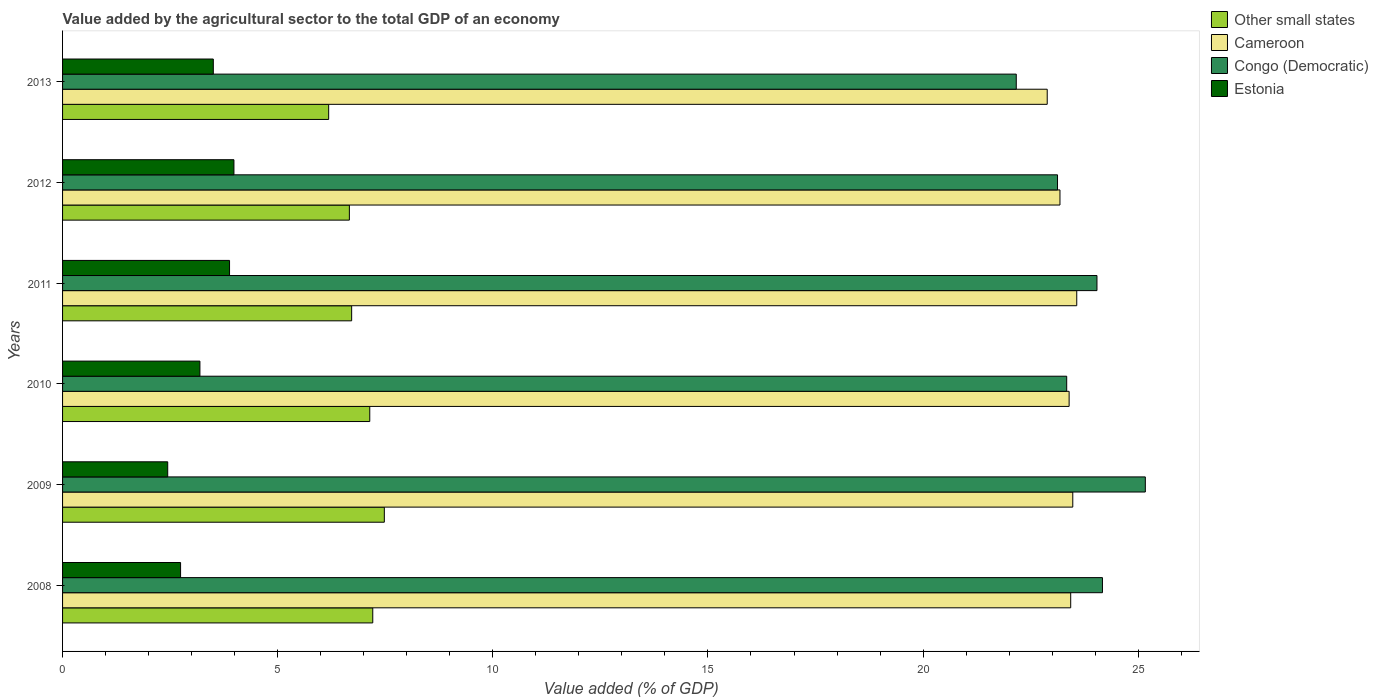Are the number of bars per tick equal to the number of legend labels?
Provide a succinct answer. Yes. Are the number of bars on each tick of the Y-axis equal?
Give a very brief answer. Yes. How many bars are there on the 5th tick from the top?
Give a very brief answer. 4. How many bars are there on the 3rd tick from the bottom?
Ensure brevity in your answer.  4. What is the value added by the agricultural sector to the total GDP in Other small states in 2011?
Keep it short and to the point. 6.72. Across all years, what is the maximum value added by the agricultural sector to the total GDP in Estonia?
Keep it short and to the point. 3.98. Across all years, what is the minimum value added by the agricultural sector to the total GDP in Other small states?
Your answer should be very brief. 6.18. In which year was the value added by the agricultural sector to the total GDP in Congo (Democratic) maximum?
Your answer should be compact. 2009. In which year was the value added by the agricultural sector to the total GDP in Cameroon minimum?
Your response must be concise. 2013. What is the total value added by the agricultural sector to the total GDP in Estonia in the graph?
Your answer should be compact. 19.75. What is the difference between the value added by the agricultural sector to the total GDP in Congo (Democratic) in 2009 and that in 2012?
Provide a short and direct response. 2.04. What is the difference between the value added by the agricultural sector to the total GDP in Estonia in 2010 and the value added by the agricultural sector to the total GDP in Congo (Democratic) in 2008?
Provide a short and direct response. -20.98. What is the average value added by the agricultural sector to the total GDP in Other small states per year?
Ensure brevity in your answer.  6.9. In the year 2009, what is the difference between the value added by the agricultural sector to the total GDP in Congo (Democratic) and value added by the agricultural sector to the total GDP in Cameroon?
Make the answer very short. 1.69. What is the ratio of the value added by the agricultural sector to the total GDP in Cameroon in 2012 to that in 2013?
Offer a very short reply. 1.01. What is the difference between the highest and the second highest value added by the agricultural sector to the total GDP in Cameroon?
Make the answer very short. 0.09. What is the difference between the highest and the lowest value added by the agricultural sector to the total GDP in Estonia?
Offer a terse response. 1.54. In how many years, is the value added by the agricultural sector to the total GDP in Congo (Democratic) greater than the average value added by the agricultural sector to the total GDP in Congo (Democratic) taken over all years?
Ensure brevity in your answer.  3. Is the sum of the value added by the agricultural sector to the total GDP in Cameroon in 2010 and 2011 greater than the maximum value added by the agricultural sector to the total GDP in Congo (Democratic) across all years?
Provide a short and direct response. Yes. What does the 2nd bar from the top in 2011 represents?
Keep it short and to the point. Congo (Democratic). What does the 4th bar from the bottom in 2009 represents?
Offer a very short reply. Estonia. Is it the case that in every year, the sum of the value added by the agricultural sector to the total GDP in Cameroon and value added by the agricultural sector to the total GDP in Congo (Democratic) is greater than the value added by the agricultural sector to the total GDP in Estonia?
Make the answer very short. Yes. Are all the bars in the graph horizontal?
Your response must be concise. Yes. Where does the legend appear in the graph?
Your response must be concise. Top right. What is the title of the graph?
Make the answer very short. Value added by the agricultural sector to the total GDP of an economy. Does "Europe(developing only)" appear as one of the legend labels in the graph?
Make the answer very short. No. What is the label or title of the X-axis?
Ensure brevity in your answer.  Value added (% of GDP). What is the label or title of the Y-axis?
Ensure brevity in your answer.  Years. What is the Value added (% of GDP) of Other small states in 2008?
Provide a succinct answer. 7.21. What is the Value added (% of GDP) in Cameroon in 2008?
Offer a terse response. 23.43. What is the Value added (% of GDP) in Congo (Democratic) in 2008?
Ensure brevity in your answer.  24.17. What is the Value added (% of GDP) in Estonia in 2008?
Keep it short and to the point. 2.74. What is the Value added (% of GDP) in Other small states in 2009?
Give a very brief answer. 7.48. What is the Value added (% of GDP) of Cameroon in 2009?
Give a very brief answer. 23.48. What is the Value added (% of GDP) in Congo (Democratic) in 2009?
Keep it short and to the point. 25.16. What is the Value added (% of GDP) in Estonia in 2009?
Ensure brevity in your answer.  2.44. What is the Value added (% of GDP) in Other small states in 2010?
Ensure brevity in your answer.  7.14. What is the Value added (% of GDP) of Cameroon in 2010?
Keep it short and to the point. 23.39. What is the Value added (% of GDP) in Congo (Democratic) in 2010?
Provide a succinct answer. 23.34. What is the Value added (% of GDP) of Estonia in 2010?
Offer a very short reply. 3.19. What is the Value added (% of GDP) of Other small states in 2011?
Ensure brevity in your answer.  6.72. What is the Value added (% of GDP) in Cameroon in 2011?
Ensure brevity in your answer.  23.57. What is the Value added (% of GDP) of Congo (Democratic) in 2011?
Your answer should be very brief. 24.04. What is the Value added (% of GDP) of Estonia in 2011?
Keep it short and to the point. 3.88. What is the Value added (% of GDP) in Other small states in 2012?
Offer a very short reply. 6.67. What is the Value added (% of GDP) in Cameroon in 2012?
Provide a short and direct response. 23.18. What is the Value added (% of GDP) in Congo (Democratic) in 2012?
Provide a succinct answer. 23.12. What is the Value added (% of GDP) in Estonia in 2012?
Offer a very short reply. 3.98. What is the Value added (% of GDP) of Other small states in 2013?
Your answer should be compact. 6.18. What is the Value added (% of GDP) of Cameroon in 2013?
Ensure brevity in your answer.  22.89. What is the Value added (% of GDP) in Congo (Democratic) in 2013?
Ensure brevity in your answer.  22.17. What is the Value added (% of GDP) in Estonia in 2013?
Make the answer very short. 3.5. Across all years, what is the maximum Value added (% of GDP) of Other small states?
Your response must be concise. 7.48. Across all years, what is the maximum Value added (% of GDP) of Cameroon?
Your response must be concise. 23.57. Across all years, what is the maximum Value added (% of GDP) of Congo (Democratic)?
Your response must be concise. 25.16. Across all years, what is the maximum Value added (% of GDP) of Estonia?
Your answer should be very brief. 3.98. Across all years, what is the minimum Value added (% of GDP) in Other small states?
Your answer should be very brief. 6.18. Across all years, what is the minimum Value added (% of GDP) in Cameroon?
Your answer should be compact. 22.89. Across all years, what is the minimum Value added (% of GDP) in Congo (Democratic)?
Give a very brief answer. 22.17. Across all years, what is the minimum Value added (% of GDP) of Estonia?
Offer a very short reply. 2.44. What is the total Value added (% of GDP) of Other small states in the graph?
Ensure brevity in your answer.  41.4. What is the total Value added (% of GDP) in Cameroon in the graph?
Provide a succinct answer. 139.94. What is the total Value added (% of GDP) in Congo (Democratic) in the graph?
Provide a short and direct response. 142. What is the total Value added (% of GDP) in Estonia in the graph?
Offer a very short reply. 19.75. What is the difference between the Value added (% of GDP) of Other small states in 2008 and that in 2009?
Make the answer very short. -0.27. What is the difference between the Value added (% of GDP) of Cameroon in 2008 and that in 2009?
Provide a short and direct response. -0.05. What is the difference between the Value added (% of GDP) in Congo (Democratic) in 2008 and that in 2009?
Your answer should be very brief. -1. What is the difference between the Value added (% of GDP) of Estonia in 2008 and that in 2009?
Provide a short and direct response. 0.3. What is the difference between the Value added (% of GDP) in Other small states in 2008 and that in 2010?
Offer a terse response. 0.07. What is the difference between the Value added (% of GDP) in Cameroon in 2008 and that in 2010?
Your answer should be very brief. 0.04. What is the difference between the Value added (% of GDP) of Congo (Democratic) in 2008 and that in 2010?
Provide a short and direct response. 0.83. What is the difference between the Value added (% of GDP) of Estonia in 2008 and that in 2010?
Provide a succinct answer. -0.45. What is the difference between the Value added (% of GDP) of Other small states in 2008 and that in 2011?
Make the answer very short. 0.49. What is the difference between the Value added (% of GDP) of Cameroon in 2008 and that in 2011?
Make the answer very short. -0.14. What is the difference between the Value added (% of GDP) of Congo (Democratic) in 2008 and that in 2011?
Give a very brief answer. 0.13. What is the difference between the Value added (% of GDP) in Estonia in 2008 and that in 2011?
Your response must be concise. -1.14. What is the difference between the Value added (% of GDP) of Other small states in 2008 and that in 2012?
Give a very brief answer. 0.54. What is the difference between the Value added (% of GDP) of Cameroon in 2008 and that in 2012?
Provide a short and direct response. 0.25. What is the difference between the Value added (% of GDP) in Congo (Democratic) in 2008 and that in 2012?
Your answer should be very brief. 1.04. What is the difference between the Value added (% of GDP) of Estonia in 2008 and that in 2012?
Offer a very short reply. -1.24. What is the difference between the Value added (% of GDP) of Cameroon in 2008 and that in 2013?
Your answer should be very brief. 0.55. What is the difference between the Value added (% of GDP) of Congo (Democratic) in 2008 and that in 2013?
Give a very brief answer. 2. What is the difference between the Value added (% of GDP) of Estonia in 2008 and that in 2013?
Your answer should be very brief. -0.76. What is the difference between the Value added (% of GDP) of Other small states in 2009 and that in 2010?
Offer a terse response. 0.34. What is the difference between the Value added (% of GDP) of Cameroon in 2009 and that in 2010?
Provide a succinct answer. 0.08. What is the difference between the Value added (% of GDP) of Congo (Democratic) in 2009 and that in 2010?
Ensure brevity in your answer.  1.83. What is the difference between the Value added (% of GDP) in Estonia in 2009 and that in 2010?
Make the answer very short. -0.75. What is the difference between the Value added (% of GDP) in Other small states in 2009 and that in 2011?
Provide a short and direct response. 0.76. What is the difference between the Value added (% of GDP) of Cameroon in 2009 and that in 2011?
Your answer should be very brief. -0.09. What is the difference between the Value added (% of GDP) in Congo (Democratic) in 2009 and that in 2011?
Ensure brevity in your answer.  1.12. What is the difference between the Value added (% of GDP) of Estonia in 2009 and that in 2011?
Offer a terse response. -1.44. What is the difference between the Value added (% of GDP) in Other small states in 2009 and that in 2012?
Give a very brief answer. 0.81. What is the difference between the Value added (% of GDP) of Cameroon in 2009 and that in 2012?
Offer a terse response. 0.3. What is the difference between the Value added (% of GDP) in Congo (Democratic) in 2009 and that in 2012?
Make the answer very short. 2.04. What is the difference between the Value added (% of GDP) in Estonia in 2009 and that in 2012?
Offer a very short reply. -1.54. What is the difference between the Value added (% of GDP) in Other small states in 2009 and that in 2013?
Keep it short and to the point. 1.29. What is the difference between the Value added (% of GDP) of Cameroon in 2009 and that in 2013?
Your answer should be very brief. 0.59. What is the difference between the Value added (% of GDP) in Congo (Democratic) in 2009 and that in 2013?
Offer a very short reply. 3. What is the difference between the Value added (% of GDP) of Estonia in 2009 and that in 2013?
Offer a very short reply. -1.06. What is the difference between the Value added (% of GDP) in Other small states in 2010 and that in 2011?
Offer a very short reply. 0.42. What is the difference between the Value added (% of GDP) in Cameroon in 2010 and that in 2011?
Keep it short and to the point. -0.18. What is the difference between the Value added (% of GDP) in Congo (Democratic) in 2010 and that in 2011?
Keep it short and to the point. -0.7. What is the difference between the Value added (% of GDP) in Estonia in 2010 and that in 2011?
Offer a terse response. -0.69. What is the difference between the Value added (% of GDP) of Other small states in 2010 and that in 2012?
Your answer should be compact. 0.47. What is the difference between the Value added (% of GDP) of Cameroon in 2010 and that in 2012?
Your answer should be very brief. 0.21. What is the difference between the Value added (% of GDP) in Congo (Democratic) in 2010 and that in 2012?
Your answer should be very brief. 0.21. What is the difference between the Value added (% of GDP) in Estonia in 2010 and that in 2012?
Provide a short and direct response. -0.79. What is the difference between the Value added (% of GDP) in Other small states in 2010 and that in 2013?
Provide a succinct answer. 0.96. What is the difference between the Value added (% of GDP) of Cameroon in 2010 and that in 2013?
Offer a terse response. 0.51. What is the difference between the Value added (% of GDP) of Congo (Democratic) in 2010 and that in 2013?
Your response must be concise. 1.17. What is the difference between the Value added (% of GDP) in Estonia in 2010 and that in 2013?
Your response must be concise. -0.31. What is the difference between the Value added (% of GDP) in Other small states in 2011 and that in 2012?
Your response must be concise. 0.05. What is the difference between the Value added (% of GDP) in Cameroon in 2011 and that in 2012?
Ensure brevity in your answer.  0.39. What is the difference between the Value added (% of GDP) in Congo (Democratic) in 2011 and that in 2012?
Keep it short and to the point. 0.92. What is the difference between the Value added (% of GDP) in Estonia in 2011 and that in 2012?
Your answer should be very brief. -0.1. What is the difference between the Value added (% of GDP) of Other small states in 2011 and that in 2013?
Offer a terse response. 0.53. What is the difference between the Value added (% of GDP) in Cameroon in 2011 and that in 2013?
Provide a succinct answer. 0.69. What is the difference between the Value added (% of GDP) in Congo (Democratic) in 2011 and that in 2013?
Provide a succinct answer. 1.88. What is the difference between the Value added (% of GDP) of Estonia in 2011 and that in 2013?
Your response must be concise. 0.38. What is the difference between the Value added (% of GDP) of Other small states in 2012 and that in 2013?
Your answer should be compact. 0.48. What is the difference between the Value added (% of GDP) in Cameroon in 2012 and that in 2013?
Provide a succinct answer. 0.3. What is the difference between the Value added (% of GDP) in Congo (Democratic) in 2012 and that in 2013?
Keep it short and to the point. 0.96. What is the difference between the Value added (% of GDP) of Estonia in 2012 and that in 2013?
Your answer should be very brief. 0.48. What is the difference between the Value added (% of GDP) in Other small states in 2008 and the Value added (% of GDP) in Cameroon in 2009?
Ensure brevity in your answer.  -16.27. What is the difference between the Value added (% of GDP) of Other small states in 2008 and the Value added (% of GDP) of Congo (Democratic) in 2009?
Give a very brief answer. -17.96. What is the difference between the Value added (% of GDP) in Other small states in 2008 and the Value added (% of GDP) in Estonia in 2009?
Your answer should be very brief. 4.77. What is the difference between the Value added (% of GDP) of Cameroon in 2008 and the Value added (% of GDP) of Congo (Democratic) in 2009?
Offer a terse response. -1.73. What is the difference between the Value added (% of GDP) in Cameroon in 2008 and the Value added (% of GDP) in Estonia in 2009?
Provide a succinct answer. 20.99. What is the difference between the Value added (% of GDP) of Congo (Democratic) in 2008 and the Value added (% of GDP) of Estonia in 2009?
Provide a short and direct response. 21.72. What is the difference between the Value added (% of GDP) in Other small states in 2008 and the Value added (% of GDP) in Cameroon in 2010?
Offer a terse response. -16.18. What is the difference between the Value added (% of GDP) in Other small states in 2008 and the Value added (% of GDP) in Congo (Democratic) in 2010?
Ensure brevity in your answer.  -16.13. What is the difference between the Value added (% of GDP) in Other small states in 2008 and the Value added (% of GDP) in Estonia in 2010?
Make the answer very short. 4.02. What is the difference between the Value added (% of GDP) of Cameroon in 2008 and the Value added (% of GDP) of Congo (Democratic) in 2010?
Your answer should be compact. 0.09. What is the difference between the Value added (% of GDP) of Cameroon in 2008 and the Value added (% of GDP) of Estonia in 2010?
Keep it short and to the point. 20.24. What is the difference between the Value added (% of GDP) in Congo (Democratic) in 2008 and the Value added (% of GDP) in Estonia in 2010?
Make the answer very short. 20.98. What is the difference between the Value added (% of GDP) in Other small states in 2008 and the Value added (% of GDP) in Cameroon in 2011?
Your answer should be compact. -16.36. What is the difference between the Value added (% of GDP) in Other small states in 2008 and the Value added (% of GDP) in Congo (Democratic) in 2011?
Your answer should be very brief. -16.83. What is the difference between the Value added (% of GDP) of Other small states in 2008 and the Value added (% of GDP) of Estonia in 2011?
Provide a succinct answer. 3.33. What is the difference between the Value added (% of GDP) in Cameroon in 2008 and the Value added (% of GDP) in Congo (Democratic) in 2011?
Make the answer very short. -0.61. What is the difference between the Value added (% of GDP) in Cameroon in 2008 and the Value added (% of GDP) in Estonia in 2011?
Provide a short and direct response. 19.55. What is the difference between the Value added (% of GDP) of Congo (Democratic) in 2008 and the Value added (% of GDP) of Estonia in 2011?
Offer a very short reply. 20.29. What is the difference between the Value added (% of GDP) in Other small states in 2008 and the Value added (% of GDP) in Cameroon in 2012?
Give a very brief answer. -15.97. What is the difference between the Value added (% of GDP) of Other small states in 2008 and the Value added (% of GDP) of Congo (Democratic) in 2012?
Provide a succinct answer. -15.91. What is the difference between the Value added (% of GDP) of Other small states in 2008 and the Value added (% of GDP) of Estonia in 2012?
Your answer should be compact. 3.23. What is the difference between the Value added (% of GDP) in Cameroon in 2008 and the Value added (% of GDP) in Congo (Democratic) in 2012?
Ensure brevity in your answer.  0.31. What is the difference between the Value added (% of GDP) in Cameroon in 2008 and the Value added (% of GDP) in Estonia in 2012?
Your response must be concise. 19.45. What is the difference between the Value added (% of GDP) of Congo (Democratic) in 2008 and the Value added (% of GDP) of Estonia in 2012?
Offer a terse response. 20.19. What is the difference between the Value added (% of GDP) in Other small states in 2008 and the Value added (% of GDP) in Cameroon in 2013?
Offer a very short reply. -15.68. What is the difference between the Value added (% of GDP) in Other small states in 2008 and the Value added (% of GDP) in Congo (Democratic) in 2013?
Offer a very short reply. -14.96. What is the difference between the Value added (% of GDP) of Other small states in 2008 and the Value added (% of GDP) of Estonia in 2013?
Provide a short and direct response. 3.71. What is the difference between the Value added (% of GDP) in Cameroon in 2008 and the Value added (% of GDP) in Congo (Democratic) in 2013?
Provide a short and direct response. 1.27. What is the difference between the Value added (% of GDP) of Cameroon in 2008 and the Value added (% of GDP) of Estonia in 2013?
Your response must be concise. 19.93. What is the difference between the Value added (% of GDP) of Congo (Democratic) in 2008 and the Value added (% of GDP) of Estonia in 2013?
Provide a short and direct response. 20.66. What is the difference between the Value added (% of GDP) in Other small states in 2009 and the Value added (% of GDP) in Cameroon in 2010?
Give a very brief answer. -15.92. What is the difference between the Value added (% of GDP) of Other small states in 2009 and the Value added (% of GDP) of Congo (Democratic) in 2010?
Keep it short and to the point. -15.86. What is the difference between the Value added (% of GDP) in Other small states in 2009 and the Value added (% of GDP) in Estonia in 2010?
Offer a very short reply. 4.29. What is the difference between the Value added (% of GDP) of Cameroon in 2009 and the Value added (% of GDP) of Congo (Democratic) in 2010?
Provide a succinct answer. 0.14. What is the difference between the Value added (% of GDP) of Cameroon in 2009 and the Value added (% of GDP) of Estonia in 2010?
Ensure brevity in your answer.  20.29. What is the difference between the Value added (% of GDP) of Congo (Democratic) in 2009 and the Value added (% of GDP) of Estonia in 2010?
Your answer should be very brief. 21.97. What is the difference between the Value added (% of GDP) in Other small states in 2009 and the Value added (% of GDP) in Cameroon in 2011?
Keep it short and to the point. -16.09. What is the difference between the Value added (% of GDP) of Other small states in 2009 and the Value added (% of GDP) of Congo (Democratic) in 2011?
Keep it short and to the point. -16.56. What is the difference between the Value added (% of GDP) of Other small states in 2009 and the Value added (% of GDP) of Estonia in 2011?
Keep it short and to the point. 3.6. What is the difference between the Value added (% of GDP) of Cameroon in 2009 and the Value added (% of GDP) of Congo (Democratic) in 2011?
Provide a succinct answer. -0.56. What is the difference between the Value added (% of GDP) of Cameroon in 2009 and the Value added (% of GDP) of Estonia in 2011?
Offer a terse response. 19.6. What is the difference between the Value added (% of GDP) of Congo (Democratic) in 2009 and the Value added (% of GDP) of Estonia in 2011?
Provide a succinct answer. 21.28. What is the difference between the Value added (% of GDP) of Other small states in 2009 and the Value added (% of GDP) of Cameroon in 2012?
Your response must be concise. -15.7. What is the difference between the Value added (% of GDP) in Other small states in 2009 and the Value added (% of GDP) in Congo (Democratic) in 2012?
Your answer should be very brief. -15.65. What is the difference between the Value added (% of GDP) in Other small states in 2009 and the Value added (% of GDP) in Estonia in 2012?
Make the answer very short. 3.5. What is the difference between the Value added (% of GDP) in Cameroon in 2009 and the Value added (% of GDP) in Congo (Democratic) in 2012?
Provide a succinct answer. 0.35. What is the difference between the Value added (% of GDP) of Cameroon in 2009 and the Value added (% of GDP) of Estonia in 2012?
Give a very brief answer. 19.5. What is the difference between the Value added (% of GDP) in Congo (Democratic) in 2009 and the Value added (% of GDP) in Estonia in 2012?
Offer a very short reply. 21.18. What is the difference between the Value added (% of GDP) in Other small states in 2009 and the Value added (% of GDP) in Cameroon in 2013?
Offer a terse response. -15.41. What is the difference between the Value added (% of GDP) in Other small states in 2009 and the Value added (% of GDP) in Congo (Democratic) in 2013?
Provide a short and direct response. -14.69. What is the difference between the Value added (% of GDP) of Other small states in 2009 and the Value added (% of GDP) of Estonia in 2013?
Give a very brief answer. 3.97. What is the difference between the Value added (% of GDP) in Cameroon in 2009 and the Value added (% of GDP) in Congo (Democratic) in 2013?
Your response must be concise. 1.31. What is the difference between the Value added (% of GDP) of Cameroon in 2009 and the Value added (% of GDP) of Estonia in 2013?
Your response must be concise. 19.98. What is the difference between the Value added (% of GDP) of Congo (Democratic) in 2009 and the Value added (% of GDP) of Estonia in 2013?
Offer a terse response. 21.66. What is the difference between the Value added (% of GDP) in Other small states in 2010 and the Value added (% of GDP) in Cameroon in 2011?
Your response must be concise. -16.43. What is the difference between the Value added (% of GDP) of Other small states in 2010 and the Value added (% of GDP) of Congo (Democratic) in 2011?
Provide a short and direct response. -16.9. What is the difference between the Value added (% of GDP) in Other small states in 2010 and the Value added (% of GDP) in Estonia in 2011?
Give a very brief answer. 3.26. What is the difference between the Value added (% of GDP) of Cameroon in 2010 and the Value added (% of GDP) of Congo (Democratic) in 2011?
Offer a terse response. -0.65. What is the difference between the Value added (% of GDP) of Cameroon in 2010 and the Value added (% of GDP) of Estonia in 2011?
Ensure brevity in your answer.  19.51. What is the difference between the Value added (% of GDP) of Congo (Democratic) in 2010 and the Value added (% of GDP) of Estonia in 2011?
Provide a short and direct response. 19.46. What is the difference between the Value added (% of GDP) in Other small states in 2010 and the Value added (% of GDP) in Cameroon in 2012?
Keep it short and to the point. -16.04. What is the difference between the Value added (% of GDP) of Other small states in 2010 and the Value added (% of GDP) of Congo (Democratic) in 2012?
Offer a very short reply. -15.98. What is the difference between the Value added (% of GDP) of Other small states in 2010 and the Value added (% of GDP) of Estonia in 2012?
Provide a short and direct response. 3.16. What is the difference between the Value added (% of GDP) of Cameroon in 2010 and the Value added (% of GDP) of Congo (Democratic) in 2012?
Your response must be concise. 0.27. What is the difference between the Value added (% of GDP) of Cameroon in 2010 and the Value added (% of GDP) of Estonia in 2012?
Your answer should be compact. 19.41. What is the difference between the Value added (% of GDP) in Congo (Democratic) in 2010 and the Value added (% of GDP) in Estonia in 2012?
Provide a short and direct response. 19.35. What is the difference between the Value added (% of GDP) in Other small states in 2010 and the Value added (% of GDP) in Cameroon in 2013?
Keep it short and to the point. -15.75. What is the difference between the Value added (% of GDP) in Other small states in 2010 and the Value added (% of GDP) in Congo (Democratic) in 2013?
Give a very brief answer. -15.03. What is the difference between the Value added (% of GDP) of Other small states in 2010 and the Value added (% of GDP) of Estonia in 2013?
Offer a terse response. 3.64. What is the difference between the Value added (% of GDP) in Cameroon in 2010 and the Value added (% of GDP) in Congo (Democratic) in 2013?
Make the answer very short. 1.23. What is the difference between the Value added (% of GDP) of Cameroon in 2010 and the Value added (% of GDP) of Estonia in 2013?
Keep it short and to the point. 19.89. What is the difference between the Value added (% of GDP) in Congo (Democratic) in 2010 and the Value added (% of GDP) in Estonia in 2013?
Your response must be concise. 19.83. What is the difference between the Value added (% of GDP) in Other small states in 2011 and the Value added (% of GDP) in Cameroon in 2012?
Offer a very short reply. -16.46. What is the difference between the Value added (% of GDP) of Other small states in 2011 and the Value added (% of GDP) of Congo (Democratic) in 2012?
Provide a succinct answer. -16.41. What is the difference between the Value added (% of GDP) in Other small states in 2011 and the Value added (% of GDP) in Estonia in 2012?
Your answer should be compact. 2.74. What is the difference between the Value added (% of GDP) of Cameroon in 2011 and the Value added (% of GDP) of Congo (Democratic) in 2012?
Ensure brevity in your answer.  0.45. What is the difference between the Value added (% of GDP) in Cameroon in 2011 and the Value added (% of GDP) in Estonia in 2012?
Provide a succinct answer. 19.59. What is the difference between the Value added (% of GDP) in Congo (Democratic) in 2011 and the Value added (% of GDP) in Estonia in 2012?
Offer a very short reply. 20.06. What is the difference between the Value added (% of GDP) of Other small states in 2011 and the Value added (% of GDP) of Cameroon in 2013?
Your answer should be very brief. -16.17. What is the difference between the Value added (% of GDP) in Other small states in 2011 and the Value added (% of GDP) in Congo (Democratic) in 2013?
Provide a succinct answer. -15.45. What is the difference between the Value added (% of GDP) in Other small states in 2011 and the Value added (% of GDP) in Estonia in 2013?
Your answer should be compact. 3.22. What is the difference between the Value added (% of GDP) in Cameroon in 2011 and the Value added (% of GDP) in Congo (Democratic) in 2013?
Your response must be concise. 1.41. What is the difference between the Value added (% of GDP) of Cameroon in 2011 and the Value added (% of GDP) of Estonia in 2013?
Provide a short and direct response. 20.07. What is the difference between the Value added (% of GDP) of Congo (Democratic) in 2011 and the Value added (% of GDP) of Estonia in 2013?
Your answer should be compact. 20.54. What is the difference between the Value added (% of GDP) of Other small states in 2012 and the Value added (% of GDP) of Cameroon in 2013?
Make the answer very short. -16.22. What is the difference between the Value added (% of GDP) of Other small states in 2012 and the Value added (% of GDP) of Congo (Democratic) in 2013?
Make the answer very short. -15.5. What is the difference between the Value added (% of GDP) of Other small states in 2012 and the Value added (% of GDP) of Estonia in 2013?
Your answer should be compact. 3.16. What is the difference between the Value added (% of GDP) in Cameroon in 2012 and the Value added (% of GDP) in Congo (Democratic) in 2013?
Offer a very short reply. 1.02. What is the difference between the Value added (% of GDP) in Cameroon in 2012 and the Value added (% of GDP) in Estonia in 2013?
Make the answer very short. 19.68. What is the difference between the Value added (% of GDP) of Congo (Democratic) in 2012 and the Value added (% of GDP) of Estonia in 2013?
Your response must be concise. 19.62. What is the average Value added (% of GDP) in Other small states per year?
Your answer should be compact. 6.9. What is the average Value added (% of GDP) in Cameroon per year?
Offer a very short reply. 23.32. What is the average Value added (% of GDP) of Congo (Democratic) per year?
Provide a short and direct response. 23.67. What is the average Value added (% of GDP) in Estonia per year?
Offer a terse response. 3.29. In the year 2008, what is the difference between the Value added (% of GDP) in Other small states and Value added (% of GDP) in Cameroon?
Your answer should be compact. -16.22. In the year 2008, what is the difference between the Value added (% of GDP) in Other small states and Value added (% of GDP) in Congo (Democratic)?
Your answer should be very brief. -16.96. In the year 2008, what is the difference between the Value added (% of GDP) of Other small states and Value added (% of GDP) of Estonia?
Your answer should be very brief. 4.47. In the year 2008, what is the difference between the Value added (% of GDP) of Cameroon and Value added (% of GDP) of Congo (Democratic)?
Offer a very short reply. -0.74. In the year 2008, what is the difference between the Value added (% of GDP) of Cameroon and Value added (% of GDP) of Estonia?
Keep it short and to the point. 20.69. In the year 2008, what is the difference between the Value added (% of GDP) in Congo (Democratic) and Value added (% of GDP) in Estonia?
Offer a terse response. 21.43. In the year 2009, what is the difference between the Value added (% of GDP) of Other small states and Value added (% of GDP) of Cameroon?
Offer a terse response. -16. In the year 2009, what is the difference between the Value added (% of GDP) of Other small states and Value added (% of GDP) of Congo (Democratic)?
Offer a very short reply. -17.69. In the year 2009, what is the difference between the Value added (% of GDP) of Other small states and Value added (% of GDP) of Estonia?
Provide a succinct answer. 5.03. In the year 2009, what is the difference between the Value added (% of GDP) of Cameroon and Value added (% of GDP) of Congo (Democratic)?
Offer a terse response. -1.69. In the year 2009, what is the difference between the Value added (% of GDP) in Cameroon and Value added (% of GDP) in Estonia?
Your response must be concise. 21.03. In the year 2009, what is the difference between the Value added (% of GDP) of Congo (Democratic) and Value added (% of GDP) of Estonia?
Provide a short and direct response. 22.72. In the year 2010, what is the difference between the Value added (% of GDP) in Other small states and Value added (% of GDP) in Cameroon?
Offer a terse response. -16.25. In the year 2010, what is the difference between the Value added (% of GDP) of Other small states and Value added (% of GDP) of Congo (Democratic)?
Ensure brevity in your answer.  -16.2. In the year 2010, what is the difference between the Value added (% of GDP) in Other small states and Value added (% of GDP) in Estonia?
Offer a very short reply. 3.95. In the year 2010, what is the difference between the Value added (% of GDP) in Cameroon and Value added (% of GDP) in Congo (Democratic)?
Offer a terse response. 0.06. In the year 2010, what is the difference between the Value added (% of GDP) of Cameroon and Value added (% of GDP) of Estonia?
Give a very brief answer. 20.2. In the year 2010, what is the difference between the Value added (% of GDP) in Congo (Democratic) and Value added (% of GDP) in Estonia?
Provide a short and direct response. 20.15. In the year 2011, what is the difference between the Value added (% of GDP) in Other small states and Value added (% of GDP) in Cameroon?
Keep it short and to the point. -16.85. In the year 2011, what is the difference between the Value added (% of GDP) of Other small states and Value added (% of GDP) of Congo (Democratic)?
Your response must be concise. -17.32. In the year 2011, what is the difference between the Value added (% of GDP) in Other small states and Value added (% of GDP) in Estonia?
Provide a short and direct response. 2.84. In the year 2011, what is the difference between the Value added (% of GDP) in Cameroon and Value added (% of GDP) in Congo (Democratic)?
Your answer should be very brief. -0.47. In the year 2011, what is the difference between the Value added (% of GDP) in Cameroon and Value added (% of GDP) in Estonia?
Offer a very short reply. 19.69. In the year 2011, what is the difference between the Value added (% of GDP) in Congo (Democratic) and Value added (% of GDP) in Estonia?
Provide a succinct answer. 20.16. In the year 2012, what is the difference between the Value added (% of GDP) in Other small states and Value added (% of GDP) in Cameroon?
Keep it short and to the point. -16.52. In the year 2012, what is the difference between the Value added (% of GDP) of Other small states and Value added (% of GDP) of Congo (Democratic)?
Keep it short and to the point. -16.46. In the year 2012, what is the difference between the Value added (% of GDP) of Other small states and Value added (% of GDP) of Estonia?
Provide a succinct answer. 2.68. In the year 2012, what is the difference between the Value added (% of GDP) of Cameroon and Value added (% of GDP) of Congo (Democratic)?
Offer a terse response. 0.06. In the year 2012, what is the difference between the Value added (% of GDP) in Cameroon and Value added (% of GDP) in Estonia?
Offer a very short reply. 19.2. In the year 2012, what is the difference between the Value added (% of GDP) in Congo (Democratic) and Value added (% of GDP) in Estonia?
Your response must be concise. 19.14. In the year 2013, what is the difference between the Value added (% of GDP) of Other small states and Value added (% of GDP) of Cameroon?
Offer a terse response. -16.7. In the year 2013, what is the difference between the Value added (% of GDP) of Other small states and Value added (% of GDP) of Congo (Democratic)?
Provide a succinct answer. -15.98. In the year 2013, what is the difference between the Value added (% of GDP) in Other small states and Value added (% of GDP) in Estonia?
Make the answer very short. 2.68. In the year 2013, what is the difference between the Value added (% of GDP) of Cameroon and Value added (% of GDP) of Congo (Democratic)?
Make the answer very short. 0.72. In the year 2013, what is the difference between the Value added (% of GDP) of Cameroon and Value added (% of GDP) of Estonia?
Your response must be concise. 19.38. In the year 2013, what is the difference between the Value added (% of GDP) in Congo (Democratic) and Value added (% of GDP) in Estonia?
Give a very brief answer. 18.66. What is the ratio of the Value added (% of GDP) of Other small states in 2008 to that in 2009?
Offer a terse response. 0.96. What is the ratio of the Value added (% of GDP) in Cameroon in 2008 to that in 2009?
Offer a terse response. 1. What is the ratio of the Value added (% of GDP) in Congo (Democratic) in 2008 to that in 2009?
Keep it short and to the point. 0.96. What is the ratio of the Value added (% of GDP) in Estonia in 2008 to that in 2009?
Your answer should be compact. 1.12. What is the ratio of the Value added (% of GDP) of Other small states in 2008 to that in 2010?
Your response must be concise. 1.01. What is the ratio of the Value added (% of GDP) in Cameroon in 2008 to that in 2010?
Your answer should be compact. 1. What is the ratio of the Value added (% of GDP) in Congo (Democratic) in 2008 to that in 2010?
Ensure brevity in your answer.  1.04. What is the ratio of the Value added (% of GDP) of Estonia in 2008 to that in 2010?
Make the answer very short. 0.86. What is the ratio of the Value added (% of GDP) in Other small states in 2008 to that in 2011?
Your answer should be very brief. 1.07. What is the ratio of the Value added (% of GDP) in Cameroon in 2008 to that in 2011?
Ensure brevity in your answer.  0.99. What is the ratio of the Value added (% of GDP) of Estonia in 2008 to that in 2011?
Your answer should be very brief. 0.71. What is the ratio of the Value added (% of GDP) in Other small states in 2008 to that in 2012?
Keep it short and to the point. 1.08. What is the ratio of the Value added (% of GDP) of Cameroon in 2008 to that in 2012?
Make the answer very short. 1.01. What is the ratio of the Value added (% of GDP) of Congo (Democratic) in 2008 to that in 2012?
Give a very brief answer. 1.05. What is the ratio of the Value added (% of GDP) in Estonia in 2008 to that in 2012?
Make the answer very short. 0.69. What is the ratio of the Value added (% of GDP) of Other small states in 2008 to that in 2013?
Your answer should be very brief. 1.17. What is the ratio of the Value added (% of GDP) in Cameroon in 2008 to that in 2013?
Give a very brief answer. 1.02. What is the ratio of the Value added (% of GDP) in Congo (Democratic) in 2008 to that in 2013?
Provide a short and direct response. 1.09. What is the ratio of the Value added (% of GDP) of Estonia in 2008 to that in 2013?
Make the answer very short. 0.78. What is the ratio of the Value added (% of GDP) of Other small states in 2009 to that in 2010?
Offer a very short reply. 1.05. What is the ratio of the Value added (% of GDP) in Cameroon in 2009 to that in 2010?
Offer a terse response. 1. What is the ratio of the Value added (% of GDP) of Congo (Democratic) in 2009 to that in 2010?
Make the answer very short. 1.08. What is the ratio of the Value added (% of GDP) in Estonia in 2009 to that in 2010?
Ensure brevity in your answer.  0.77. What is the ratio of the Value added (% of GDP) of Other small states in 2009 to that in 2011?
Provide a succinct answer. 1.11. What is the ratio of the Value added (% of GDP) of Cameroon in 2009 to that in 2011?
Your answer should be compact. 1. What is the ratio of the Value added (% of GDP) of Congo (Democratic) in 2009 to that in 2011?
Provide a short and direct response. 1.05. What is the ratio of the Value added (% of GDP) in Estonia in 2009 to that in 2011?
Offer a very short reply. 0.63. What is the ratio of the Value added (% of GDP) of Other small states in 2009 to that in 2012?
Offer a very short reply. 1.12. What is the ratio of the Value added (% of GDP) in Cameroon in 2009 to that in 2012?
Make the answer very short. 1.01. What is the ratio of the Value added (% of GDP) in Congo (Democratic) in 2009 to that in 2012?
Keep it short and to the point. 1.09. What is the ratio of the Value added (% of GDP) of Estonia in 2009 to that in 2012?
Make the answer very short. 0.61. What is the ratio of the Value added (% of GDP) of Other small states in 2009 to that in 2013?
Offer a very short reply. 1.21. What is the ratio of the Value added (% of GDP) of Cameroon in 2009 to that in 2013?
Offer a very short reply. 1.03. What is the ratio of the Value added (% of GDP) of Congo (Democratic) in 2009 to that in 2013?
Give a very brief answer. 1.14. What is the ratio of the Value added (% of GDP) in Estonia in 2009 to that in 2013?
Offer a terse response. 0.7. What is the ratio of the Value added (% of GDP) of Other small states in 2010 to that in 2011?
Your answer should be compact. 1.06. What is the ratio of the Value added (% of GDP) in Cameroon in 2010 to that in 2011?
Ensure brevity in your answer.  0.99. What is the ratio of the Value added (% of GDP) in Congo (Democratic) in 2010 to that in 2011?
Offer a terse response. 0.97. What is the ratio of the Value added (% of GDP) in Estonia in 2010 to that in 2011?
Offer a very short reply. 0.82. What is the ratio of the Value added (% of GDP) in Other small states in 2010 to that in 2012?
Offer a very short reply. 1.07. What is the ratio of the Value added (% of GDP) in Cameroon in 2010 to that in 2012?
Make the answer very short. 1.01. What is the ratio of the Value added (% of GDP) of Congo (Democratic) in 2010 to that in 2012?
Your answer should be very brief. 1.01. What is the ratio of the Value added (% of GDP) of Estonia in 2010 to that in 2012?
Your answer should be very brief. 0.8. What is the ratio of the Value added (% of GDP) of Other small states in 2010 to that in 2013?
Offer a very short reply. 1.15. What is the ratio of the Value added (% of GDP) of Cameroon in 2010 to that in 2013?
Provide a short and direct response. 1.02. What is the ratio of the Value added (% of GDP) in Congo (Democratic) in 2010 to that in 2013?
Keep it short and to the point. 1.05. What is the ratio of the Value added (% of GDP) in Estonia in 2010 to that in 2013?
Your answer should be very brief. 0.91. What is the ratio of the Value added (% of GDP) of Other small states in 2011 to that in 2012?
Your answer should be very brief. 1.01. What is the ratio of the Value added (% of GDP) in Cameroon in 2011 to that in 2012?
Offer a terse response. 1.02. What is the ratio of the Value added (% of GDP) in Congo (Democratic) in 2011 to that in 2012?
Offer a terse response. 1.04. What is the ratio of the Value added (% of GDP) in Estonia in 2011 to that in 2012?
Your response must be concise. 0.97. What is the ratio of the Value added (% of GDP) of Other small states in 2011 to that in 2013?
Provide a short and direct response. 1.09. What is the ratio of the Value added (% of GDP) of Congo (Democratic) in 2011 to that in 2013?
Your response must be concise. 1.08. What is the ratio of the Value added (% of GDP) of Estonia in 2011 to that in 2013?
Ensure brevity in your answer.  1.11. What is the ratio of the Value added (% of GDP) of Other small states in 2012 to that in 2013?
Provide a short and direct response. 1.08. What is the ratio of the Value added (% of GDP) in Cameroon in 2012 to that in 2013?
Offer a very short reply. 1.01. What is the ratio of the Value added (% of GDP) in Congo (Democratic) in 2012 to that in 2013?
Keep it short and to the point. 1.04. What is the ratio of the Value added (% of GDP) in Estonia in 2012 to that in 2013?
Ensure brevity in your answer.  1.14. What is the difference between the highest and the second highest Value added (% of GDP) of Other small states?
Keep it short and to the point. 0.27. What is the difference between the highest and the second highest Value added (% of GDP) of Cameroon?
Offer a terse response. 0.09. What is the difference between the highest and the second highest Value added (% of GDP) of Estonia?
Your response must be concise. 0.1. What is the difference between the highest and the lowest Value added (% of GDP) in Other small states?
Provide a succinct answer. 1.29. What is the difference between the highest and the lowest Value added (% of GDP) of Cameroon?
Your answer should be compact. 0.69. What is the difference between the highest and the lowest Value added (% of GDP) of Congo (Democratic)?
Ensure brevity in your answer.  3. What is the difference between the highest and the lowest Value added (% of GDP) of Estonia?
Offer a terse response. 1.54. 